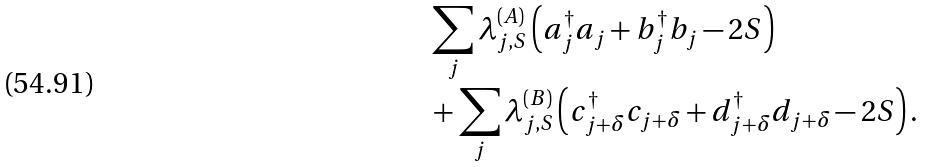Convert formula to latex. <formula><loc_0><loc_0><loc_500><loc_500>& \sum _ { j } \lambda _ { j , S } ^ { ( A ) } \left ( a _ { j } ^ { \dag } a _ { j } + b _ { j } ^ { \dag } b _ { j } - 2 S \right ) \\ & + \sum _ { j } \lambda _ { j , S } ^ { ( B ) } \left ( c _ { j + \delta } ^ { \dag } c _ { j + \delta } + d _ { j + \delta } ^ { \dag } d _ { j + \delta } - 2 S \right ) .</formula> 